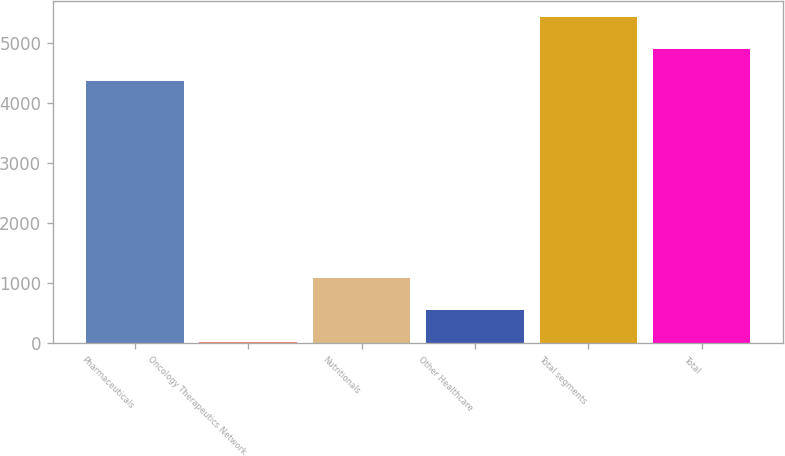Convert chart to OTSL. <chart><loc_0><loc_0><loc_500><loc_500><bar_chart><fcel>Pharmaceuticals<fcel>Oncology Therapeutics Network<fcel>Nutritionals<fcel>Other Healthcare<fcel>Total segments<fcel>Total<nl><fcel>4369<fcel>14<fcel>1077.8<fcel>545.9<fcel>5432.8<fcel>4900.9<nl></chart> 